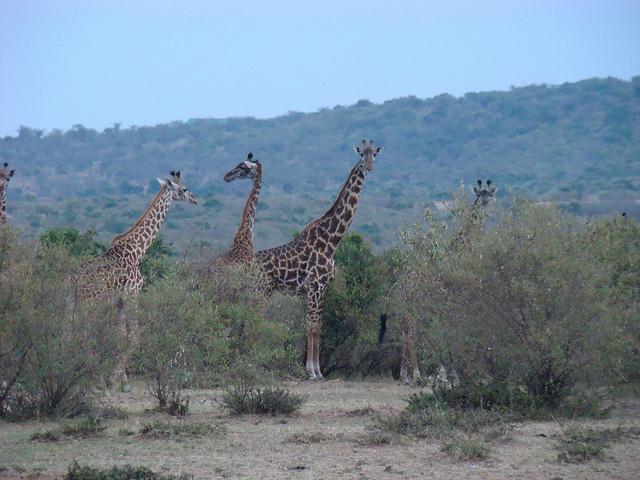Are all the giraffes looking in the same direction?
Write a very short answer. No. Are the giraffes using camouflage?
Write a very short answer. No. Are these giraffes all the same height?
Short answer required. No. 